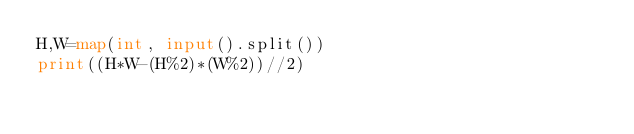Convert code to text. <code><loc_0><loc_0><loc_500><loc_500><_Python_>H,W=map(int, input().split())
print((H*W-(H%2)*(W%2))//2)</code> 